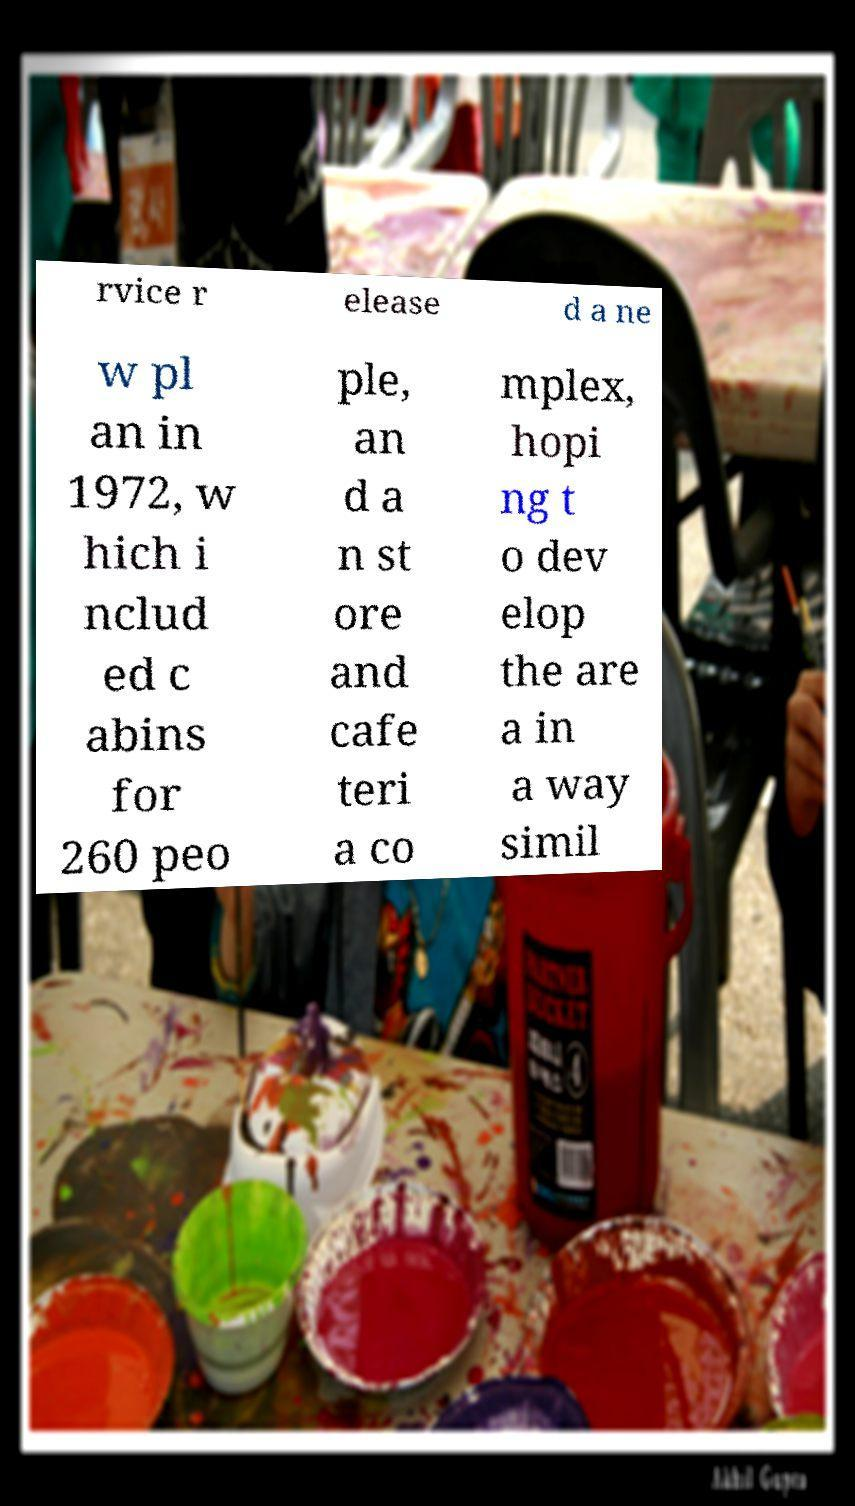There's text embedded in this image that I need extracted. Can you transcribe it verbatim? rvice r elease d a ne w pl an in 1972, w hich i nclud ed c abins for 260 peo ple, an d a n st ore and cafe teri a co mplex, hopi ng t o dev elop the are a in a way simil 